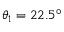Convert formula to latex. <formula><loc_0><loc_0><loc_500><loc_500>\theta _ { 1 } = 2 2 . 5 ^ { \circ }</formula> 